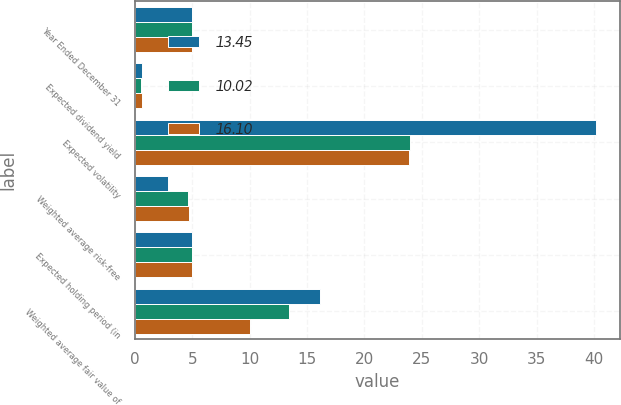<chart> <loc_0><loc_0><loc_500><loc_500><stacked_bar_chart><ecel><fcel>Year Ended December 31<fcel>Expected dividend yield<fcel>Expected volatility<fcel>Weighted average risk-free<fcel>Expected holding period (in<fcel>Weighted average fair value of<nl><fcel>13.45<fcel>5<fcel>0.6<fcel>40.2<fcel>2.9<fcel>5<fcel>16.1<nl><fcel>10.02<fcel>5<fcel>0.5<fcel>24<fcel>4.6<fcel>5<fcel>13.45<nl><fcel>16.1<fcel>5<fcel>0.6<fcel>23.9<fcel>4.7<fcel>5<fcel>10.02<nl></chart> 